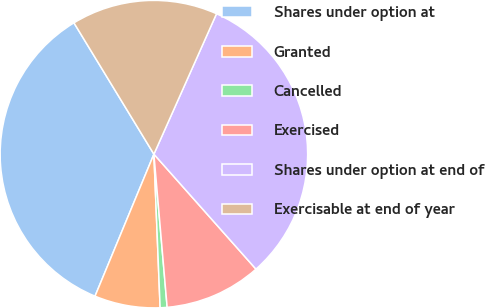Convert chart to OTSL. <chart><loc_0><loc_0><loc_500><loc_500><pie_chart><fcel>Shares under option at<fcel>Granted<fcel>Cancelled<fcel>Exercised<fcel>Shares under option at end of<fcel>Exercisable at end of year<nl><fcel>35.04%<fcel>6.9%<fcel>0.73%<fcel>10.18%<fcel>31.77%<fcel>15.38%<nl></chart> 